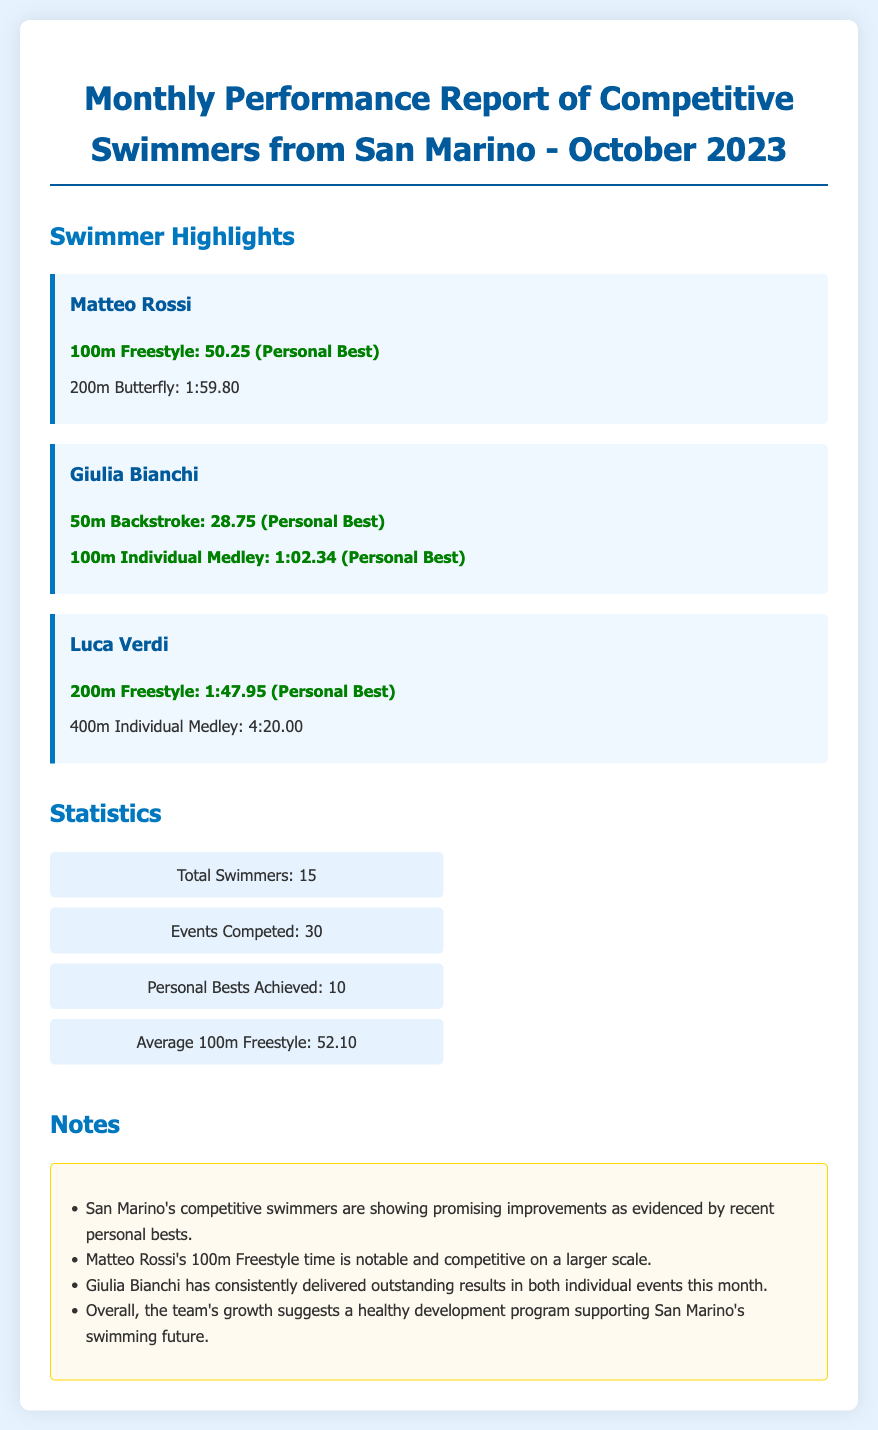What swimmer achieved a personal best in the 100m Freestyle? Matteo Rossi is highlighted as achieving a personal best in the 100m Freestyle event.
Answer: Matteo Rossi How many personal bests were achieved in total? The report states that there were 10 personal bests achieved by the swimmers.
Answer: 10 What is Giulia Bianchi's personal best in the 50m Backstroke? The document notes that Giulia Bianchi’s personal best in the 50m Backstroke is 28.75.
Answer: 28.75 What is the average time for the 100m Freestyle among the swimmers? The average time for the 100m Freestyle is provided as 52.10 in the statistics section.
Answer: 52.10 Which swimmer is noted for delivering outstanding results this month? Giulia Bianchi is specifically mentioned for consistently delivering outstanding results in her events this month.
Answer: Giulia Bianchi How many total events were competed in? The report includes a statistic stating that 30 events were competed in by the swimmers.
Answer: 30 What is Luca Verdi's personal best time in the 200m Freestyle? The document states that Luca Verdi achieved a personal best time of 1:47.95 in the 200m Freestyle.
Answer: 1:47.95 What does the note mention about the team's growth? The note mentions that the team’s growth suggests a healthy development program supporting swimming in San Marino.
Answer: A healthy development program Which event had both of Giulia Bianchi's personal bests? Giulia Bianchi achieved her personal bests in the 50m Backstroke and the 100m Individual Medley.
Answer: 100m Individual Medley 